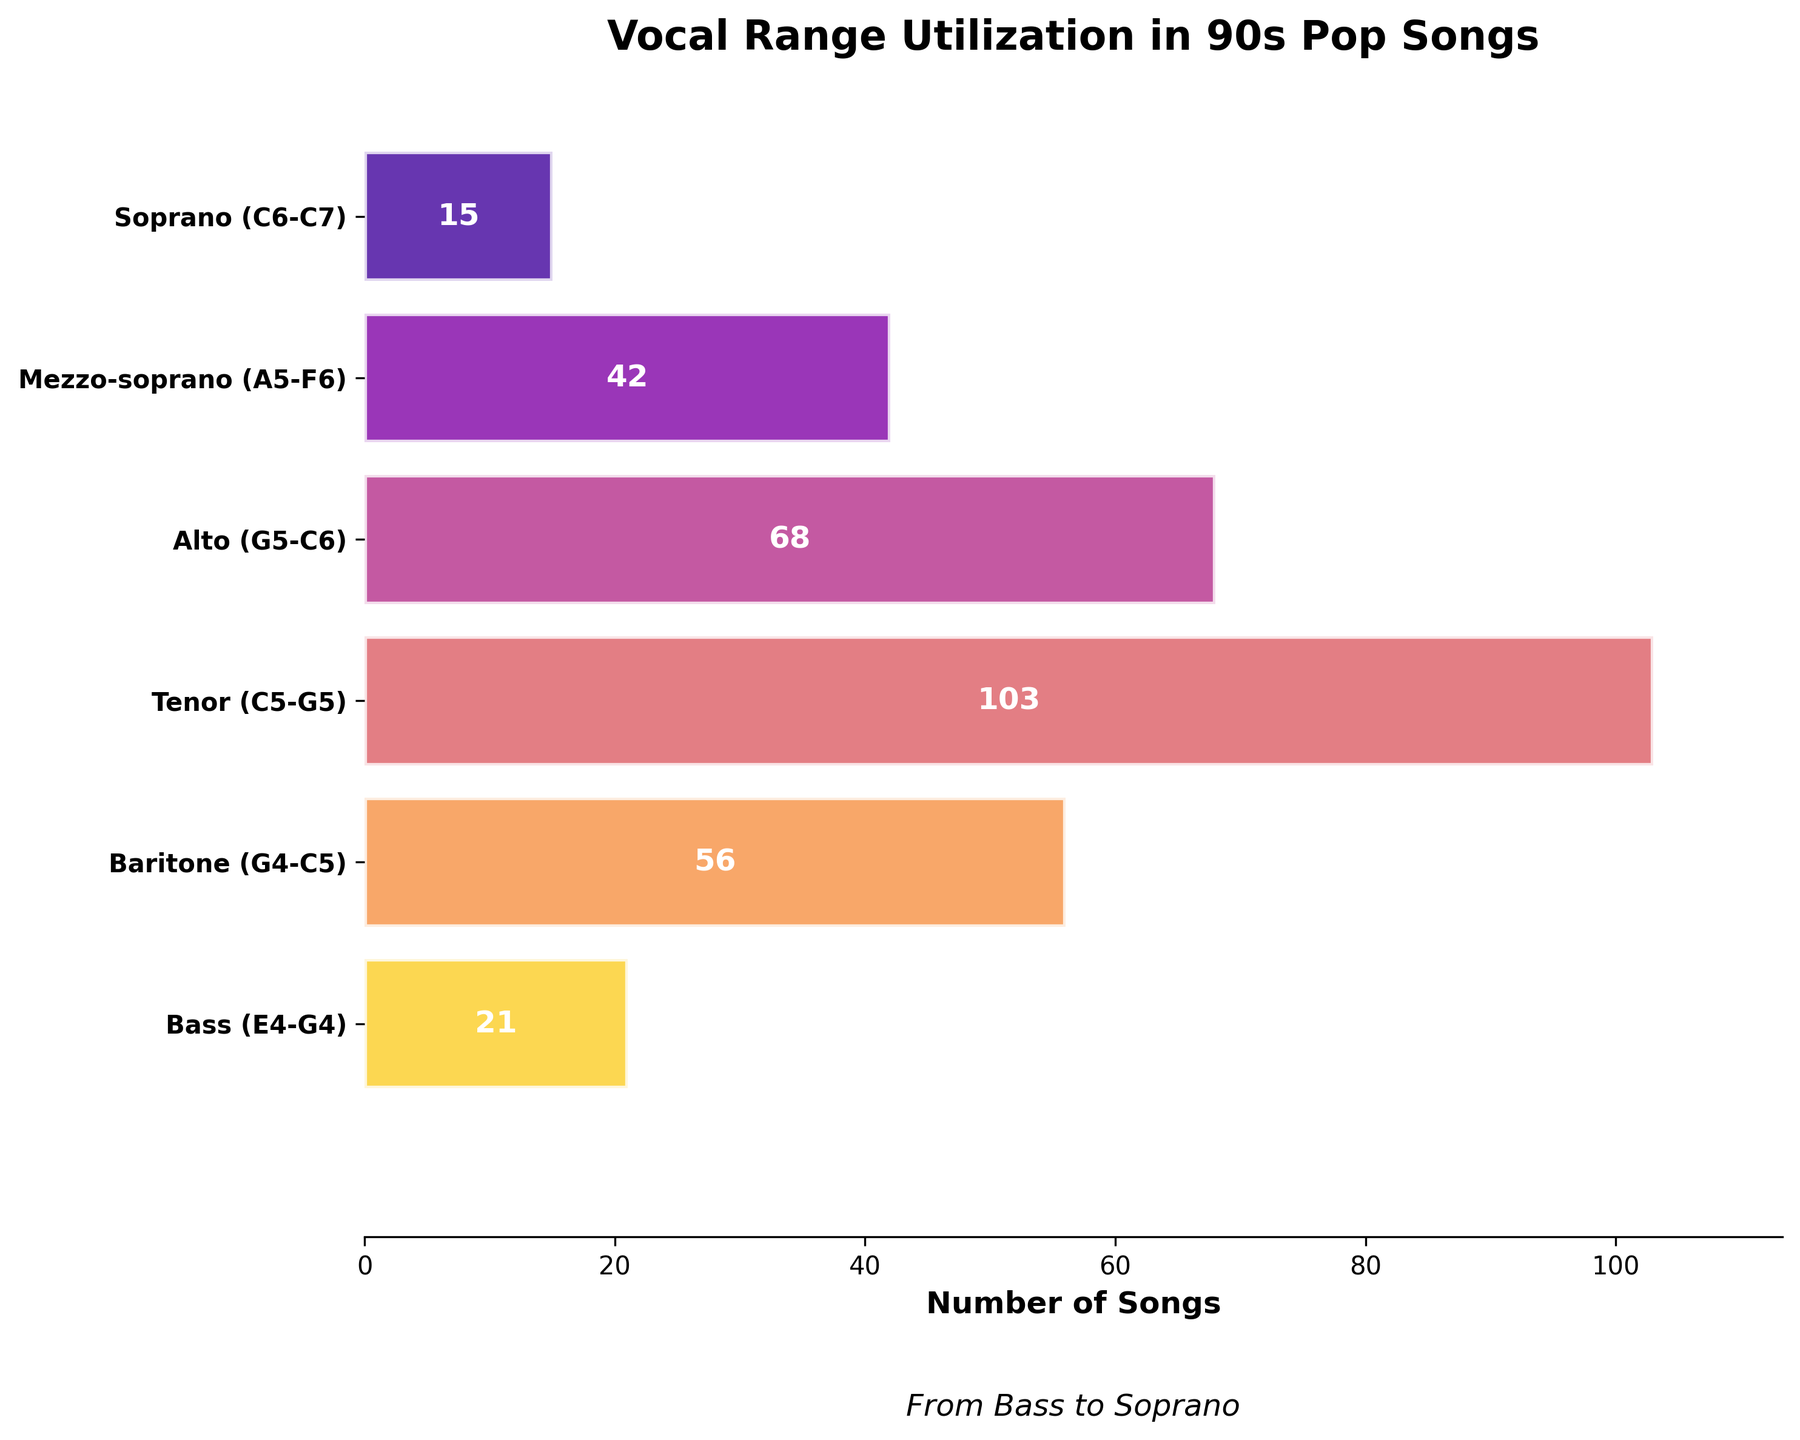what is the title of the chart? The title is typically located at the top of the chart, and it's clearly labeled. Here, it reads "Vocal Range Utilization in 90s Pop Songs"
Answer: Vocal Range Utilization in 90s Pop Songs Which vocal range has the highest number of songs? By observing the lengths of the bars, the longest bar represents the Tenor range. The numbers also validate this with Tenor having the highest number at 103
Answer: Tenor How many more songs are in the Alto range compared to the Bass range? The number of songs for Alto is 68 and for Bass is 21. The difference is calculated by subtracting the number of songs in the Bass range from the Alto range: 68 - 21 = 47
Answer: 47 What is the combined total number of songs in the Baritone and Soprano ranges? Adding the number of songs in the Baritone range (56) and the Soprano range (15), we get: 56 + 15 = 71
Answer: 71 Which vocal range has fewer songs, Bass or Mezzo-soprano? Comparing the numbers for Bass (21 songs) and Mezzo-soprano (42 songs) shows that Bass has fewer songs
Answer: Bass How does the number of songs in the Tenor range compare to the Mezzo-soprano range? The Tenor range has 103 songs and the Mezzo-soprano range has 42 songs. By comparing these, we see that the Tenor range has 61 more songs than the Mezzo-soprano range (103 - 42 = 61)
Answer: 61 more songs What's the range of the number of songs in different vocal categories, from the smallest to the largest? The range is determined by subtracting the smallest value from the largest value among the data points. Here, the smallest is Bass with 21 songs and the largest is Tenor with 103 songs: 103 - 21 = 82
Answer: 82 How many stages are there in total for vocal ranges? Each unique vocal range category counts as one stage. By counting the categories, we find: Soprano, Mezzo-soprano, Alto, Tenor, Baritone, Bass. In total, there are 6 stages
Answer: 6 Which vocal range comes immediately before Soprano in the chart? Observing the arrangement from lowest to highest notes in the chart, the stage that directly precedes the Soprano range (C6-C7) is Mezzo-soprano (A5-F6)
Answer: Mezzo-soprano 